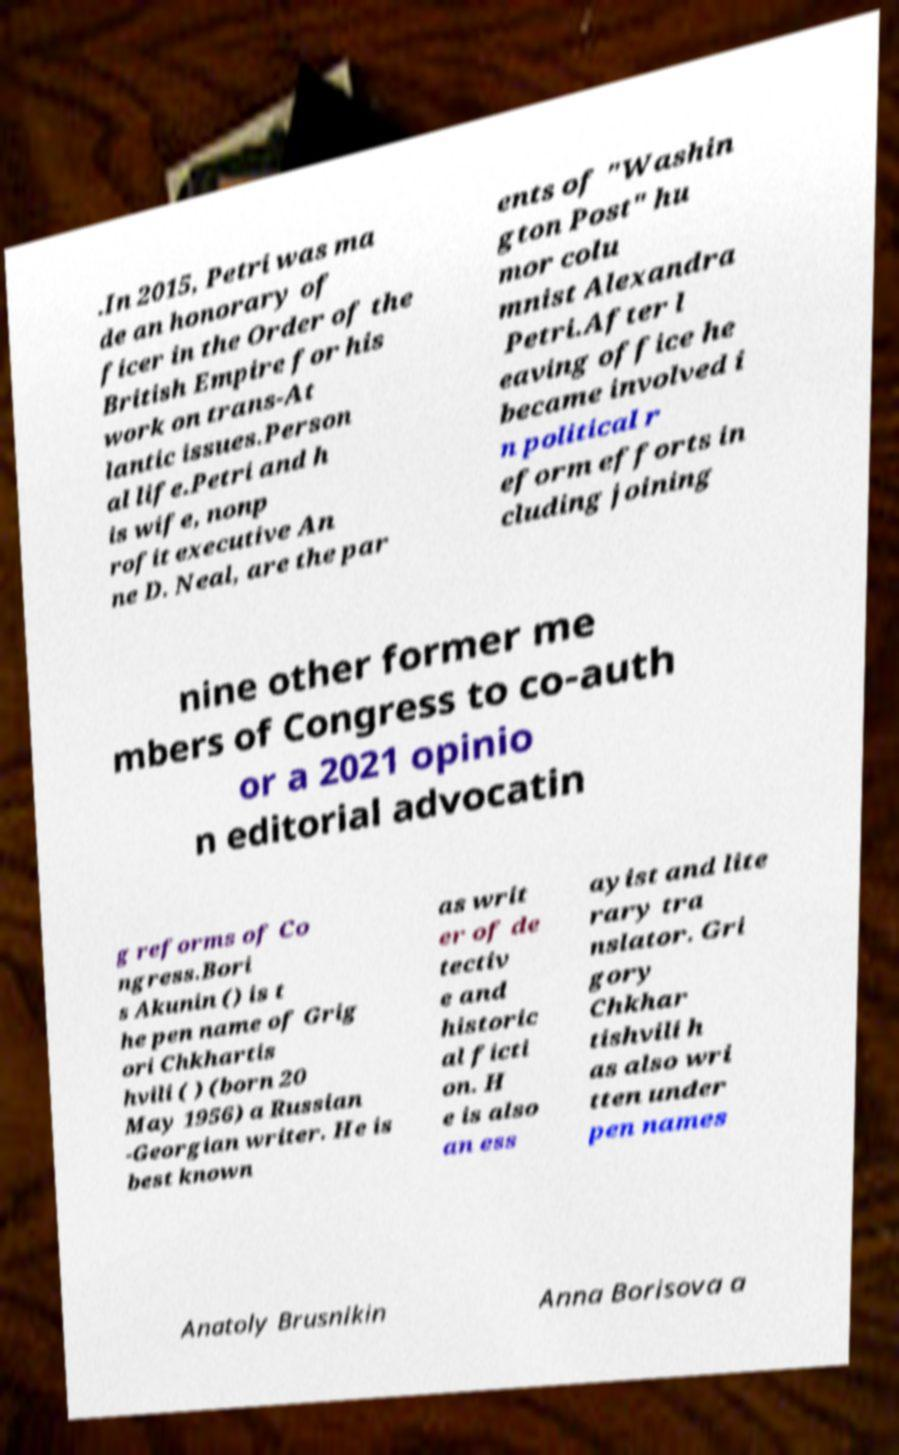Can you accurately transcribe the text from the provided image for me? .In 2015, Petri was ma de an honorary of ficer in the Order of the British Empire for his work on trans-At lantic issues.Person al life.Petri and h is wife, nonp rofit executive An ne D. Neal, are the par ents of "Washin gton Post" hu mor colu mnist Alexandra Petri.After l eaving office he became involved i n political r eform efforts in cluding joining nine other former me mbers of Congress to co-auth or a 2021 opinio n editorial advocatin g reforms of Co ngress.Bori s Akunin () is t he pen name of Grig ori Chkhartis hvili ( ) (born 20 May 1956) a Russian -Georgian writer. He is best known as writ er of de tectiv e and historic al ficti on. H e is also an ess ayist and lite rary tra nslator. Gri gory Chkhar tishvili h as also wri tten under pen names Anatoly Brusnikin Anna Borisova a 